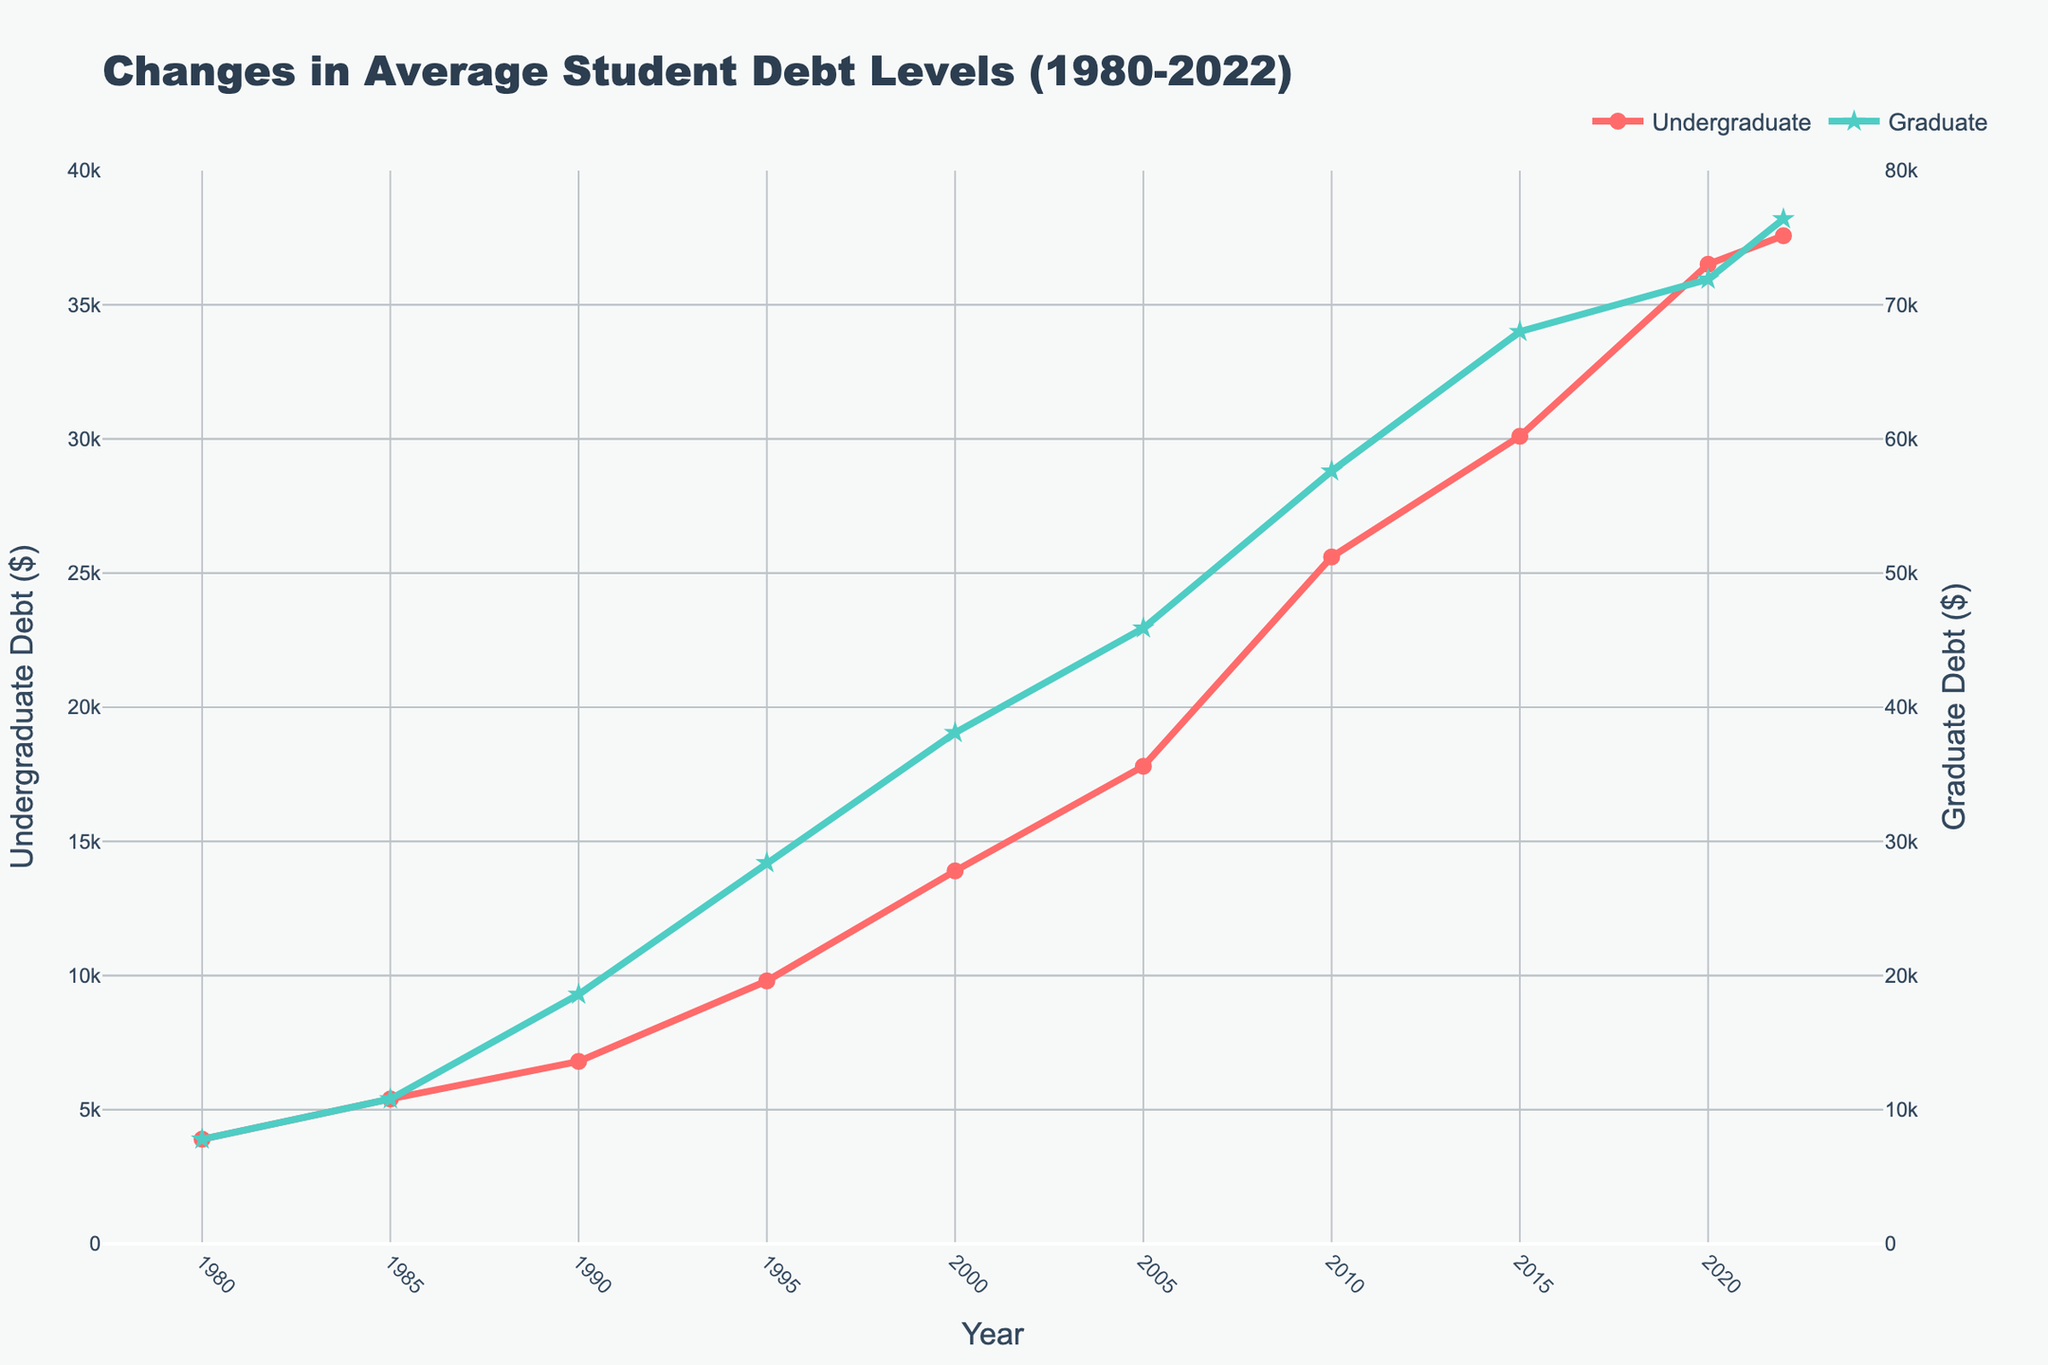What's the highest average debt level for graduate students? The highest average debt level for graduate students occurs in 2022, which is shown by the highest point on the green line. The value is 76400.
Answer: 76400 In what year did the average undergraduate debt level surpass $10,000? To find this, look at the red line and identify the year where the vertical position surpasses $10,000. This occurs in 1995 when the average undergraduate debt level is 9800.
Answer: 1995 How much did the average undergraduate debt level increase from 1980 to 2022? In 1980, the average undergraduate debt level is 3900. In 2022, it is 37574. The increase is calculated as 37574 - 3900 = 33674.
Answer: 33674 By how much did the average graduate debt level increase between 2000 and 2020? In 2000, the average graduate debt level is 38100. In 2020, it is 71900. The increase is calculated as 71900 - 38100 = 33800.
Answer: 33800 Which category had a faster growth rate in debt from 2005 to 2022: undergraduate or graduate? For undergraduate debt: 2022 value is 37574, and 2005 value is 17800, so growth is 37574 - 17800 = 19774. For graduate debt: 2022 value is 76400, and 2005 value is 45900, so growth is 76400 - 45900 = 30500. The average undergraduate debt rose by 19774, while graduate debt rose by 30500.
Answer: Graduate In which year was the ratio of graduate to undergraduate debt highest? To find this, compare the ratios for each year (Graduate Debt / Undergraduate Debt). Calculate for each year: 
1980: 7800 / 3900 = 2
1985: 10800 / 5400 = 2
1990: 18600 / 6800 ≈ 2.74
1995: 28400 / 9800 ≈ 2.9
2000: 38100 / 13900 ≈ 2.74
2005: 45900 / 17800 ≈ 2.58
2010: 57600 / 25600 ≈ 2.25
2015: 68000 / 30100 ≈ 2.26
2020: 71900 / 36510 ≈ 1.97
2022: 76400 / 37574 ≈ 2.04. The highest ratio is in 1995, approximately 2.9.
Answer: 1995 What visual elements distinguish undergraduate and graduate debt lines? The undergraduate debt line is red with circle markers, while the graduate debt line is green with star markers. These visual distinctions make it easy to differentiate the two lines at a glance.
Answer: Color and markers What is the average increase per year in undergraduate debt from 1980 to 2022? The overall increase from 1980 to 2022 is 37574 - 3900 = 33674. The number of years is 2022 - 1980 = 42. The average annual increase is 33674 / 42 ≈ 801.76.
Answer: ≈ 801.76 